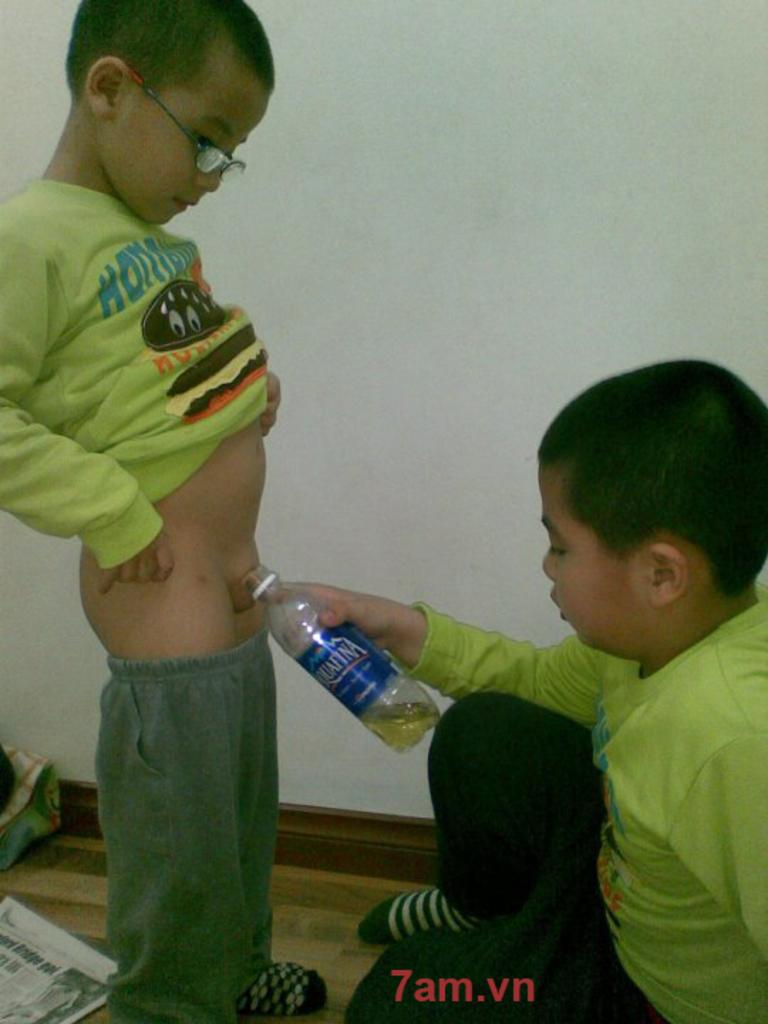What is the main subject of the image? The main subject of the image is a kid. What is the kid doing in the image? The kid is filling a bottle. What is the position of the kid in the image? The kid is standing on the floor and also sitting on the floor. What book is the kid reading in the image? There is no book present in the image, and the kid is not reading. What type of chain is the kid holding in the image? There is no chain present in the image. 